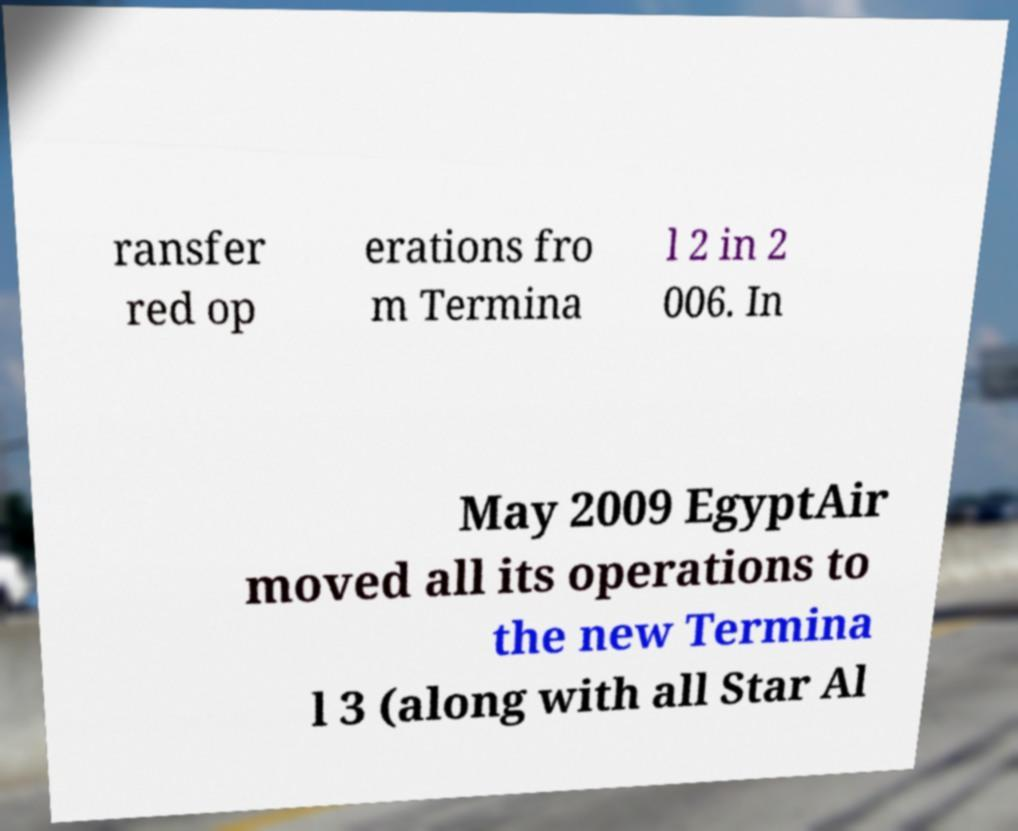I need the written content from this picture converted into text. Can you do that? ransfer red op erations fro m Termina l 2 in 2 006. In May 2009 EgyptAir moved all its operations to the new Termina l 3 (along with all Star Al 